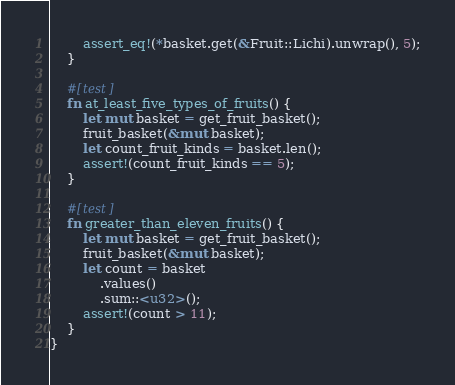<code> <loc_0><loc_0><loc_500><loc_500><_Rust_>        assert_eq!(*basket.get(&Fruit::Lichi).unwrap(), 5);
    }

    #[test]
    fn at_least_five_types_of_fruits() {
        let mut basket = get_fruit_basket();
        fruit_basket(&mut basket);
        let count_fruit_kinds = basket.len();
        assert!(count_fruit_kinds == 5);
    }

    #[test]
    fn greater_than_eleven_fruits() {
        let mut basket = get_fruit_basket();
        fruit_basket(&mut basket);
        let count = basket
            .values()
            .sum::<u32>();
        assert!(count > 11);
    }
}
</code> 